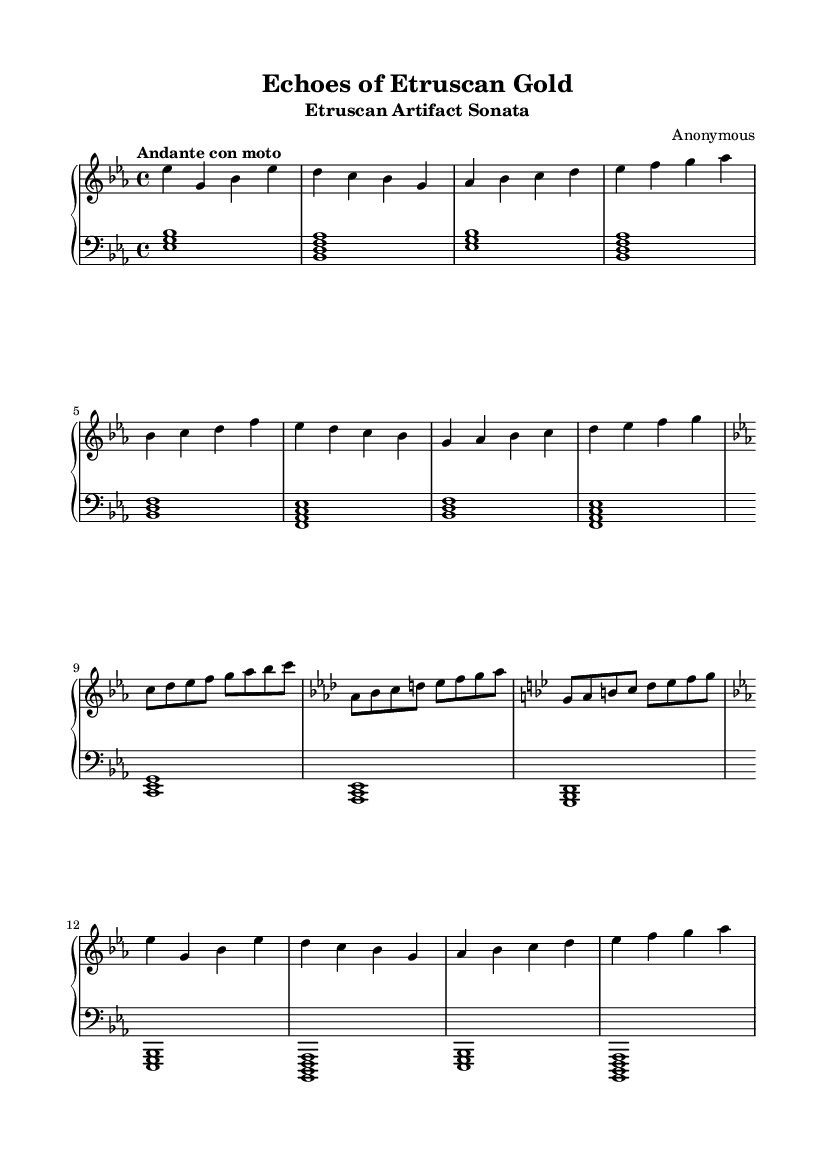What is the key signature of this music? The key signature of the piece is E flat major, which is indicated by three flat signs on the staff (B flat, E flat, and A flat).
Answer: E flat major What is the time signature of this music? The time signature displayed on the sheet music indicates a 4/4 time, meaning there are four beats in each measure and a quarter note receives one beat.
Answer: 4/4 What is the tempo marking of this sonata? The tempo marking is "Andante con moto," which indicates a moderately slow tempo with a slightly lively character, reflecting the romantic style.
Answer: Andante con moto How many themes are present in the exposition section? In the exposition, there are two main themes present: the primary theme and the secondary theme. The sheet music distinctly separates the two parts.
Answer: Two What is the key change that occurs during the development? In the development section, the music transitions to C minor, as indicated by the key signature changing on the staff. This reflects the contrasting harmonic explorations typical of the Romantic era.
Answer: C minor How is the texture of the music characterized in the lower staff? The lower staff features a homophonic texture primarily characterized by block chords. This texture supports the melody in the upper staff, typical of Romantic piano sonatas.
Answer: Homophonic What era of music does this sheet represent? The sheet music is representative of the Romantic era, characterized by expressive themes, emotional depth, and expanded harmonic language, aligning with the historical context suggested by the title.
Answer: Romantic era 